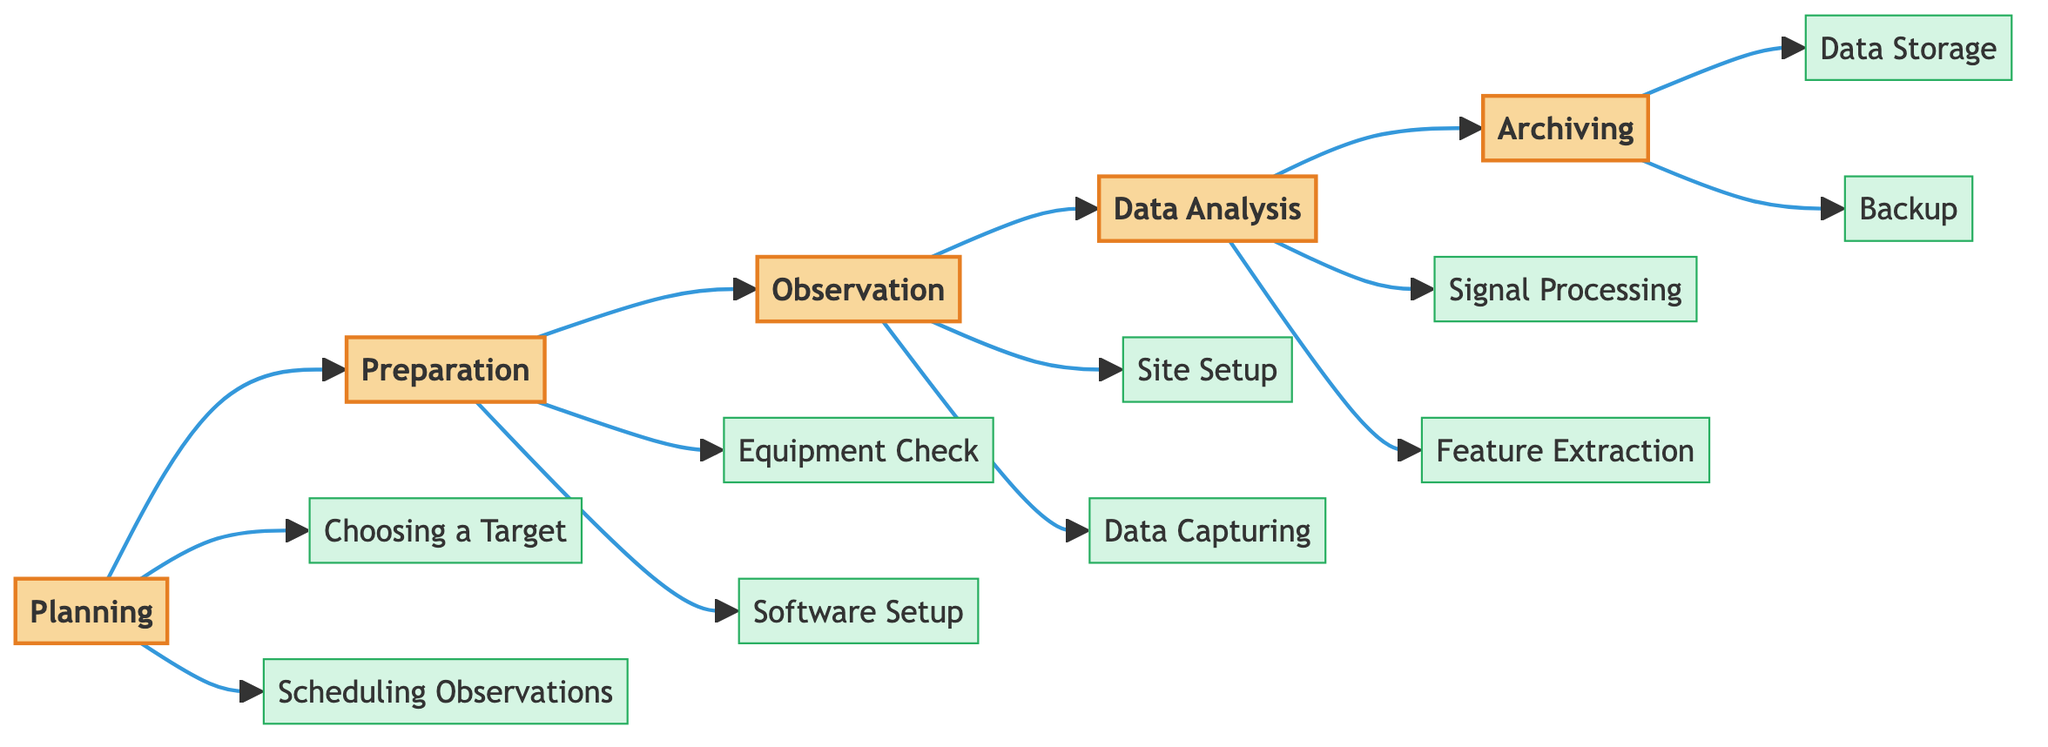What is the first step in the workflow? The first node in the horizontal flowchart is "Planning," indicating that planning is the initial step in the workflow.
Answer: Planning How many main steps are there in the workflow? The diagram presents five main steps: Planning, Preparation, Observation, Data Analysis, and Archiving. Therefore, the total number of main steps is five.
Answer: 5 Which step directly follows "Preparation"? Following the "Preparation" step in the flowchart is the "Observation" step, as indicated by the arrows connecting these two nodes sequentially.
Answer: Observation What are the two subelements of the "Planning" step? The subelements of the "Planning" step are "Choosing a Target" and "Scheduling Observations," which are connected to the "Planning" node in the diagram.
Answer: Choosing a Target, Scheduling Observations How many subelements does the "Archiving" step have? The "Archiving" step consists of two subelements: "Data Storage" and "Backup," as indicated in the diagram. Therefore, the total number of subelements is two.
Answer: 2 What is the last step in the workflow? The final node in the horizontal flowchart is "Archiving," which indicates that this is the concluding step in the workflow of astronomical observation sessions.
Answer: Archiving Which steps have subelements related to equipment? The "Preparation" step, which includes "Equipment Check," along with the "Observation" step, which involves "Site Setup," both pertain to equipment in the workflow.
Answer: Preparation, Observation What role does "Signal Processing" play in the workflow? "Signal Processing" appears in the "Data Analysis" step, indicating that it is a process undertaken after observation to enhance the captured audio signals.
Answer: Data Analysis What is the relationship between "Data Capturing" and "Site Setup"? In the flowchart, "Site Setup" is part of the "Observation" step, and "Data Capturing" follows within the same step, indicating that site preparation is necessary before capturing data.
Answer: Sequential Relationship 